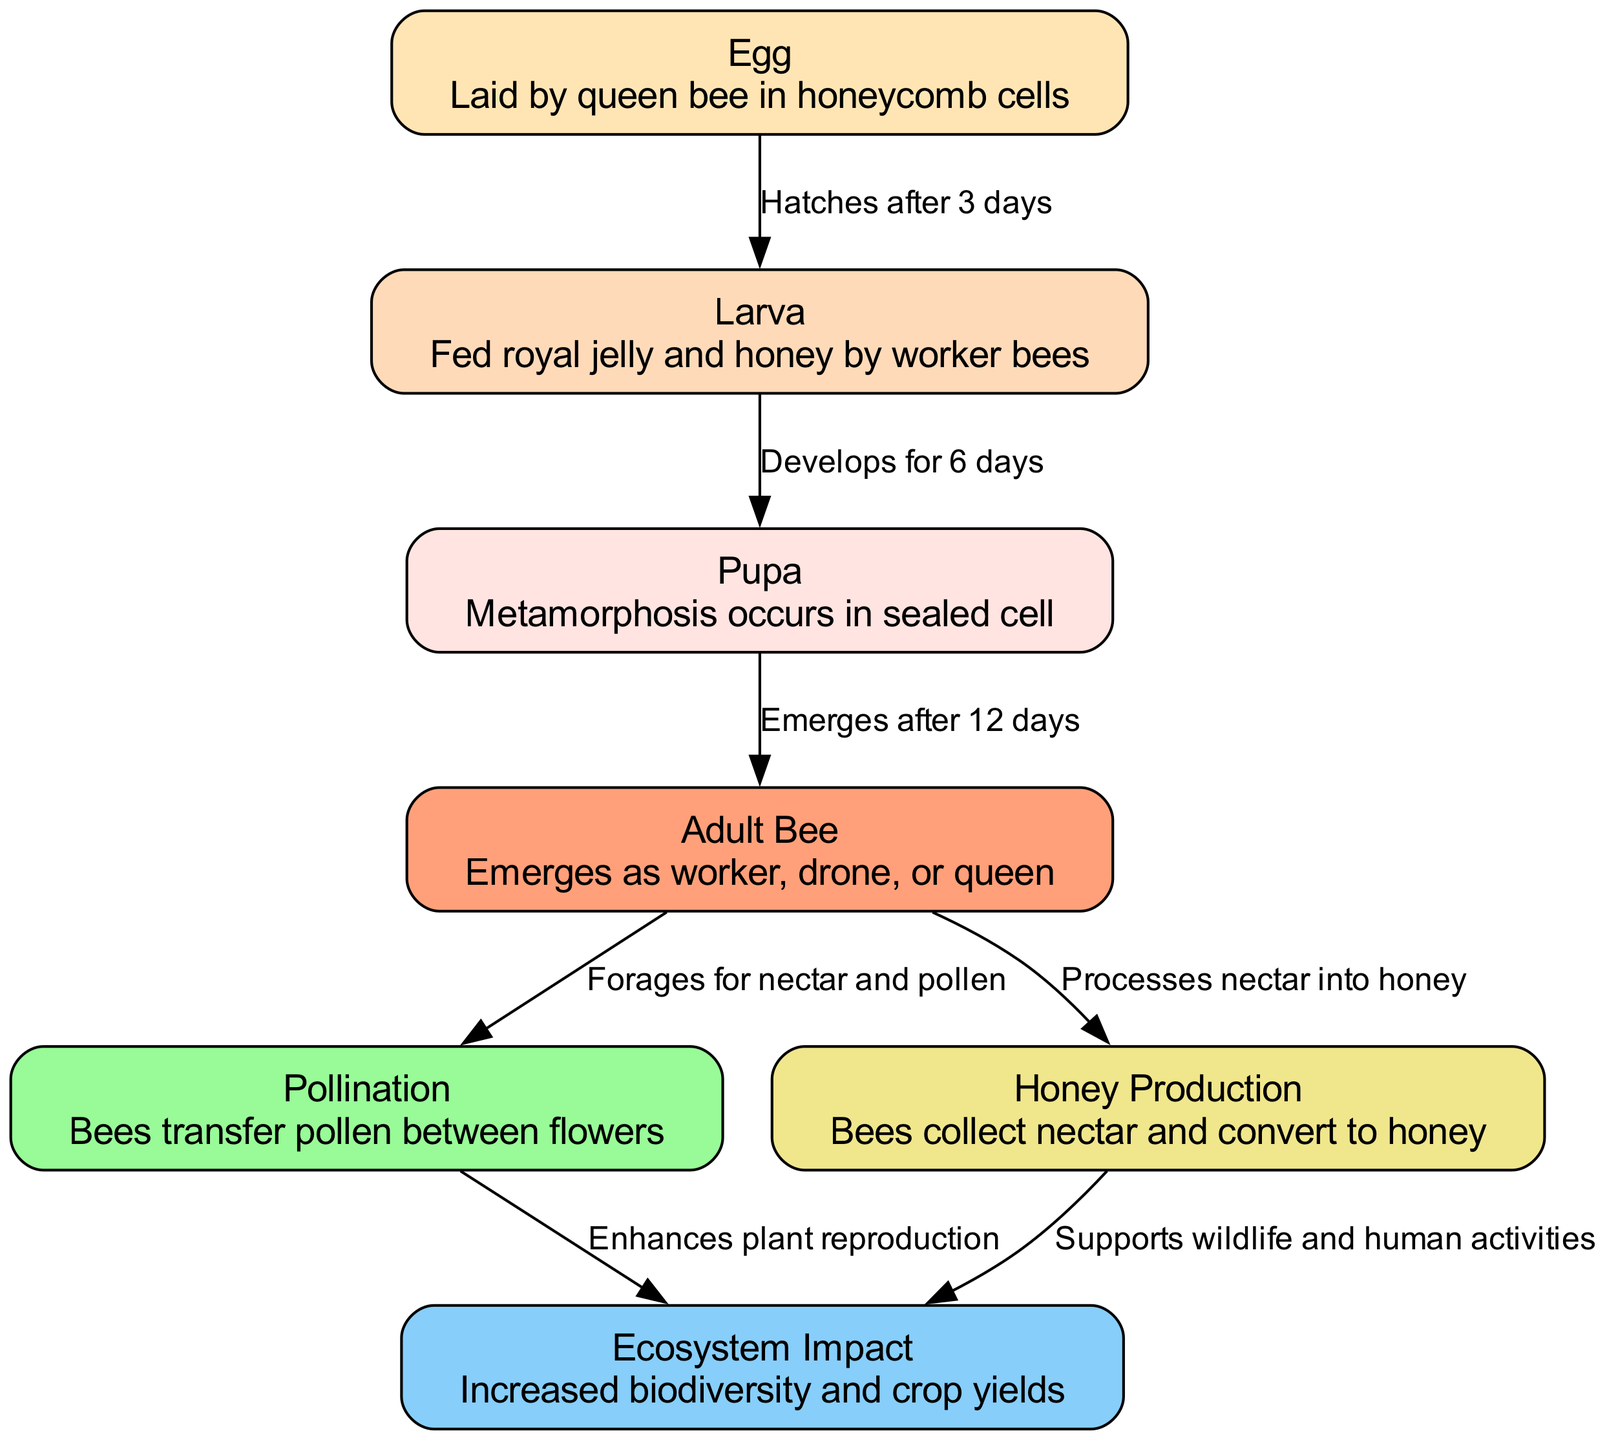What is the first stage in the lifecycle of the African honey bee? According to the diagram, the lifecycle begins with the "Egg" stage, which is laid by the queen bee in honeycomb cells.
Answer: Egg How long does it take for the egg to hatch? The diagram indicates that the egg hatches into a larva after "3 days."
Answer: 3 days What stage comes after the larva? In the sequence shown in the diagram, the larva develops into the "Pupa" stage.
Answer: Pupa What are the three types of adult bees that emerge? The diagram shows that the adult bee can emerge as a "worker," "drone," or "queen."
Answer: worker, drone, queen What process do adult bees perform foraging for nectar? The adult bees engage in "Pollination," which involves transferring pollen between flowers.
Answer: Pollination How does pollination impact the ecosystem? The diagram illustrates that pollination enhances plant reproduction, leading to increased biodiversity and crop yields.
Answer: Enhances plant reproduction What is produced from the nectar collected by adult bees? According to the diagram, the nectar collected is converted into "Honey."
Answer: Honey How many edges connect to the "Ecosystem Impact" node? The diagram shows that there are two edges connecting to the "Ecosystem Impact" node: one from "Pollination" and another from "Honey Production."
Answer: 2 What time period does the entire lifecycle from egg to adult cover? The diagram indicates that the lifecycle consists of a total period of 21 days: 3 days for the egg, 6 days for larva, and 12 days for the pupa.
Answer: 21 days What are the consequences of honey production mentioned in the diagram? The diagram specifies that honey production supports "wildlife and human activities."
Answer: Supports wildlife and human activities 